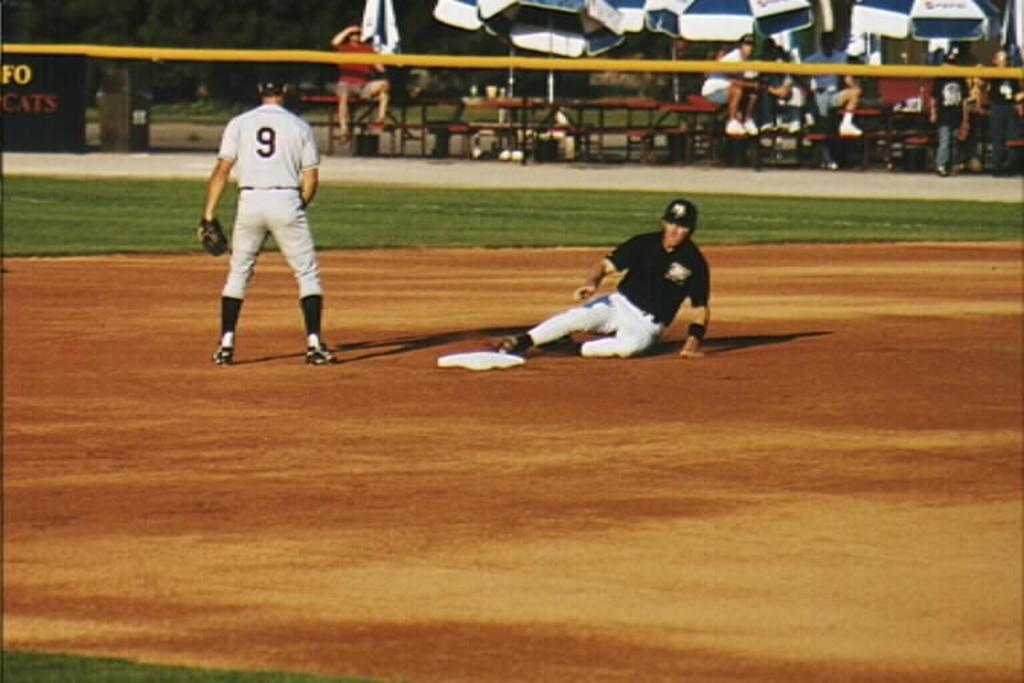<image>
Create a compact narrative representing the image presented. A player is sliding in to base as player 9 watches. 